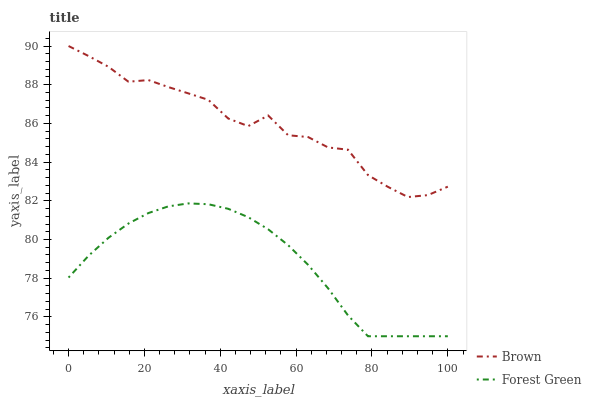Does Forest Green have the maximum area under the curve?
Answer yes or no. No. Is Forest Green the roughest?
Answer yes or no. No. Does Forest Green have the highest value?
Answer yes or no. No. Is Forest Green less than Brown?
Answer yes or no. Yes. Is Brown greater than Forest Green?
Answer yes or no. Yes. Does Forest Green intersect Brown?
Answer yes or no. No. 